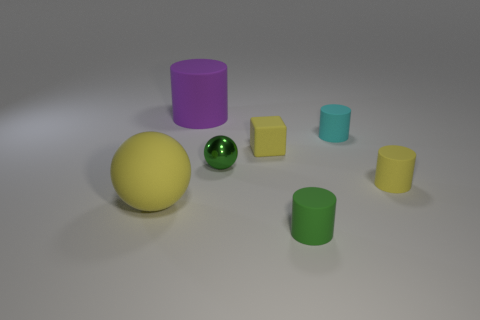What number of other objects are there of the same color as the shiny thing?
Provide a short and direct response. 1. How many yellow objects are either big things or rubber blocks?
Your answer should be very brief. 2. Are there the same number of large rubber cylinders right of the tiny cyan matte cylinder and tiny green metal spheres?
Provide a succinct answer. No. Are there any other things that are the same size as the yellow matte block?
Keep it short and to the point. Yes. The other big thing that is the same shape as the green matte object is what color?
Ensure brevity in your answer.  Purple. What number of big purple rubber objects have the same shape as the tiny green metallic object?
Ensure brevity in your answer.  0. What is the material of the cylinder that is the same color as the shiny object?
Your answer should be compact. Rubber. How many big cyan rubber things are there?
Keep it short and to the point. 0. Is there a green cylinder that has the same material as the yellow sphere?
Keep it short and to the point. Yes. There is a matte ball that is the same color as the cube; what is its size?
Keep it short and to the point. Large. 